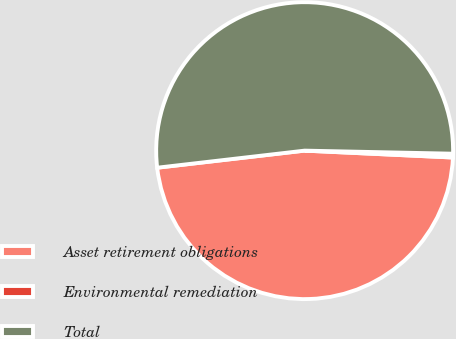Convert chart to OTSL. <chart><loc_0><loc_0><loc_500><loc_500><pie_chart><fcel>Asset retirement obligations<fcel>Environmental remediation<fcel>Total<nl><fcel>47.43%<fcel>0.41%<fcel>52.17%<nl></chart> 